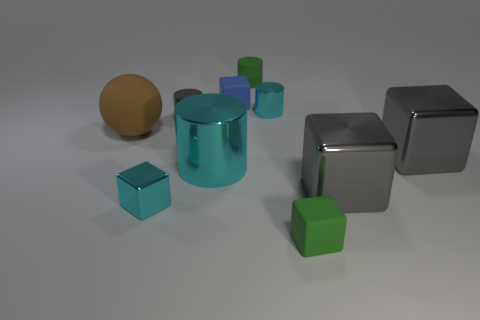There is a tiny green thing that is the same shape as the tiny blue matte object; what is it made of?
Offer a very short reply. Rubber. There is a tiny cyan cube; are there any tiny gray cylinders on the right side of it?
Make the answer very short. Yes. Are the green thing that is behind the green rubber block and the green block made of the same material?
Your response must be concise. Yes. Are there any metallic objects of the same color as the large shiny cylinder?
Offer a very short reply. Yes. What is the shape of the blue object?
Provide a succinct answer. Cube. There is a small matte block that is behind the cyan metal cylinder that is to the right of the blue rubber block; what color is it?
Your answer should be compact. Blue. There is a cyan cylinder that is in front of the big matte ball; what size is it?
Give a very brief answer. Large. Are there any gray things made of the same material as the big brown sphere?
Ensure brevity in your answer.  No. How many tiny cyan metal things have the same shape as the large cyan thing?
Keep it short and to the point. 1. What is the shape of the green object in front of the tiny metallic cylinder that is to the left of the small rubber cube behind the large cyan shiny object?
Offer a terse response. Cube. 